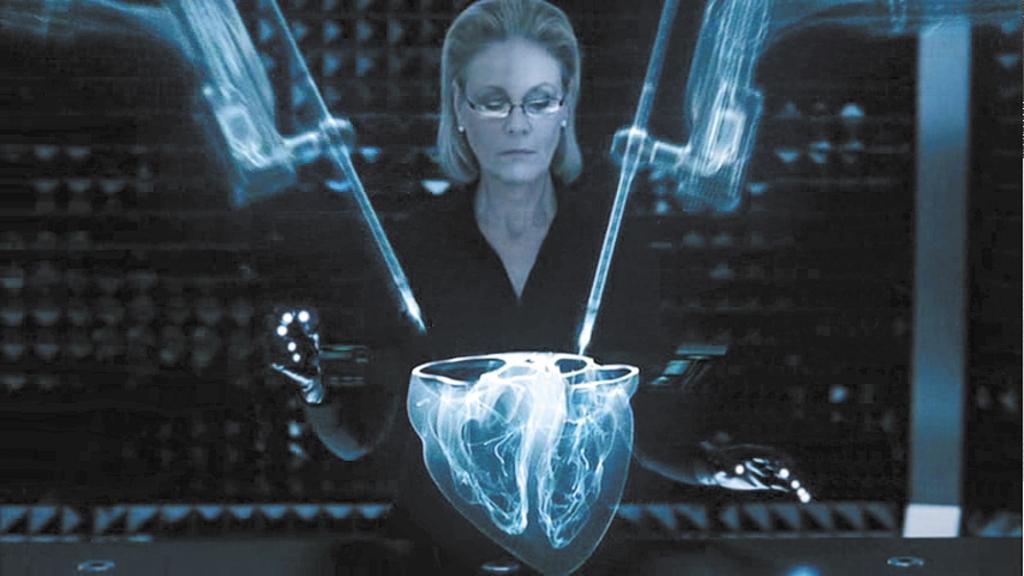In one or two sentences, can you explain what this image depicts? In this image we can see a lady wearing specs. Also there is graphical effect on the image 